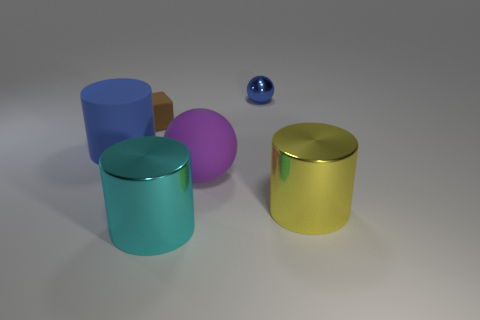Subtract all metallic cylinders. How many cylinders are left? 1 Add 3 large cyan objects. How many objects exist? 9 Subtract all blue balls. How many balls are left? 1 Subtract all spheres. How many objects are left? 4 Subtract 1 spheres. How many spheres are left? 1 Subtract all green balls. Subtract all blue cylinders. How many balls are left? 2 Subtract all blue cylinders. How many purple balls are left? 1 Add 2 red rubber things. How many red rubber things exist? 2 Subtract 1 purple balls. How many objects are left? 5 Subtract all brown metallic spheres. Subtract all big things. How many objects are left? 2 